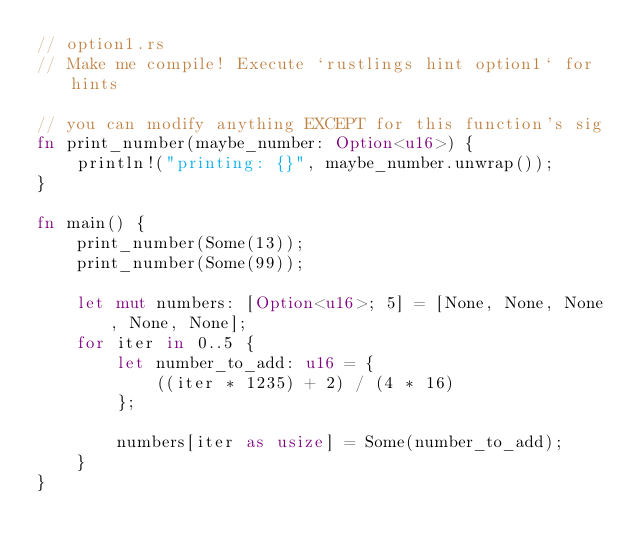<code> <loc_0><loc_0><loc_500><loc_500><_Rust_>// option1.rs
// Make me compile! Execute `rustlings hint option1` for hints

// you can modify anything EXCEPT for this function's sig
fn print_number(maybe_number: Option<u16>) {
    println!("printing: {}", maybe_number.unwrap());
}

fn main() {
    print_number(Some(13));
    print_number(Some(99));

    let mut numbers: [Option<u16>; 5] = [None, None, None, None, None];
    for iter in 0..5 {
        let number_to_add: u16 = {
            ((iter * 1235) + 2) / (4 * 16)
        };

        numbers[iter as usize] = Some(number_to_add);
    }
}
</code> 